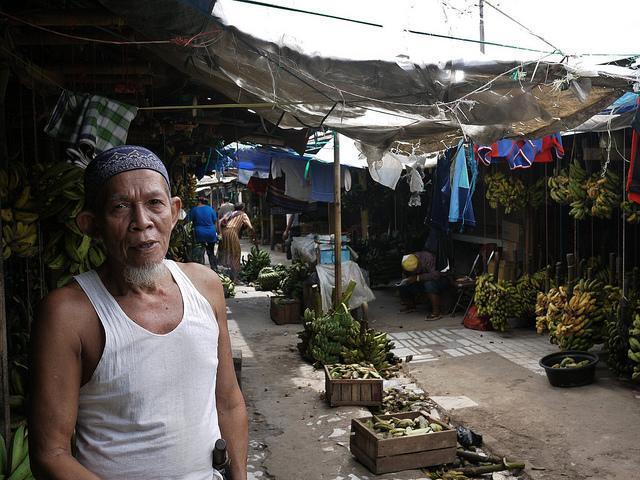How many people are visible in the scene?
Give a very brief answer. 5. How many people can be seen?
Give a very brief answer. 2. How many bananas are in the photo?
Give a very brief answer. 3. 